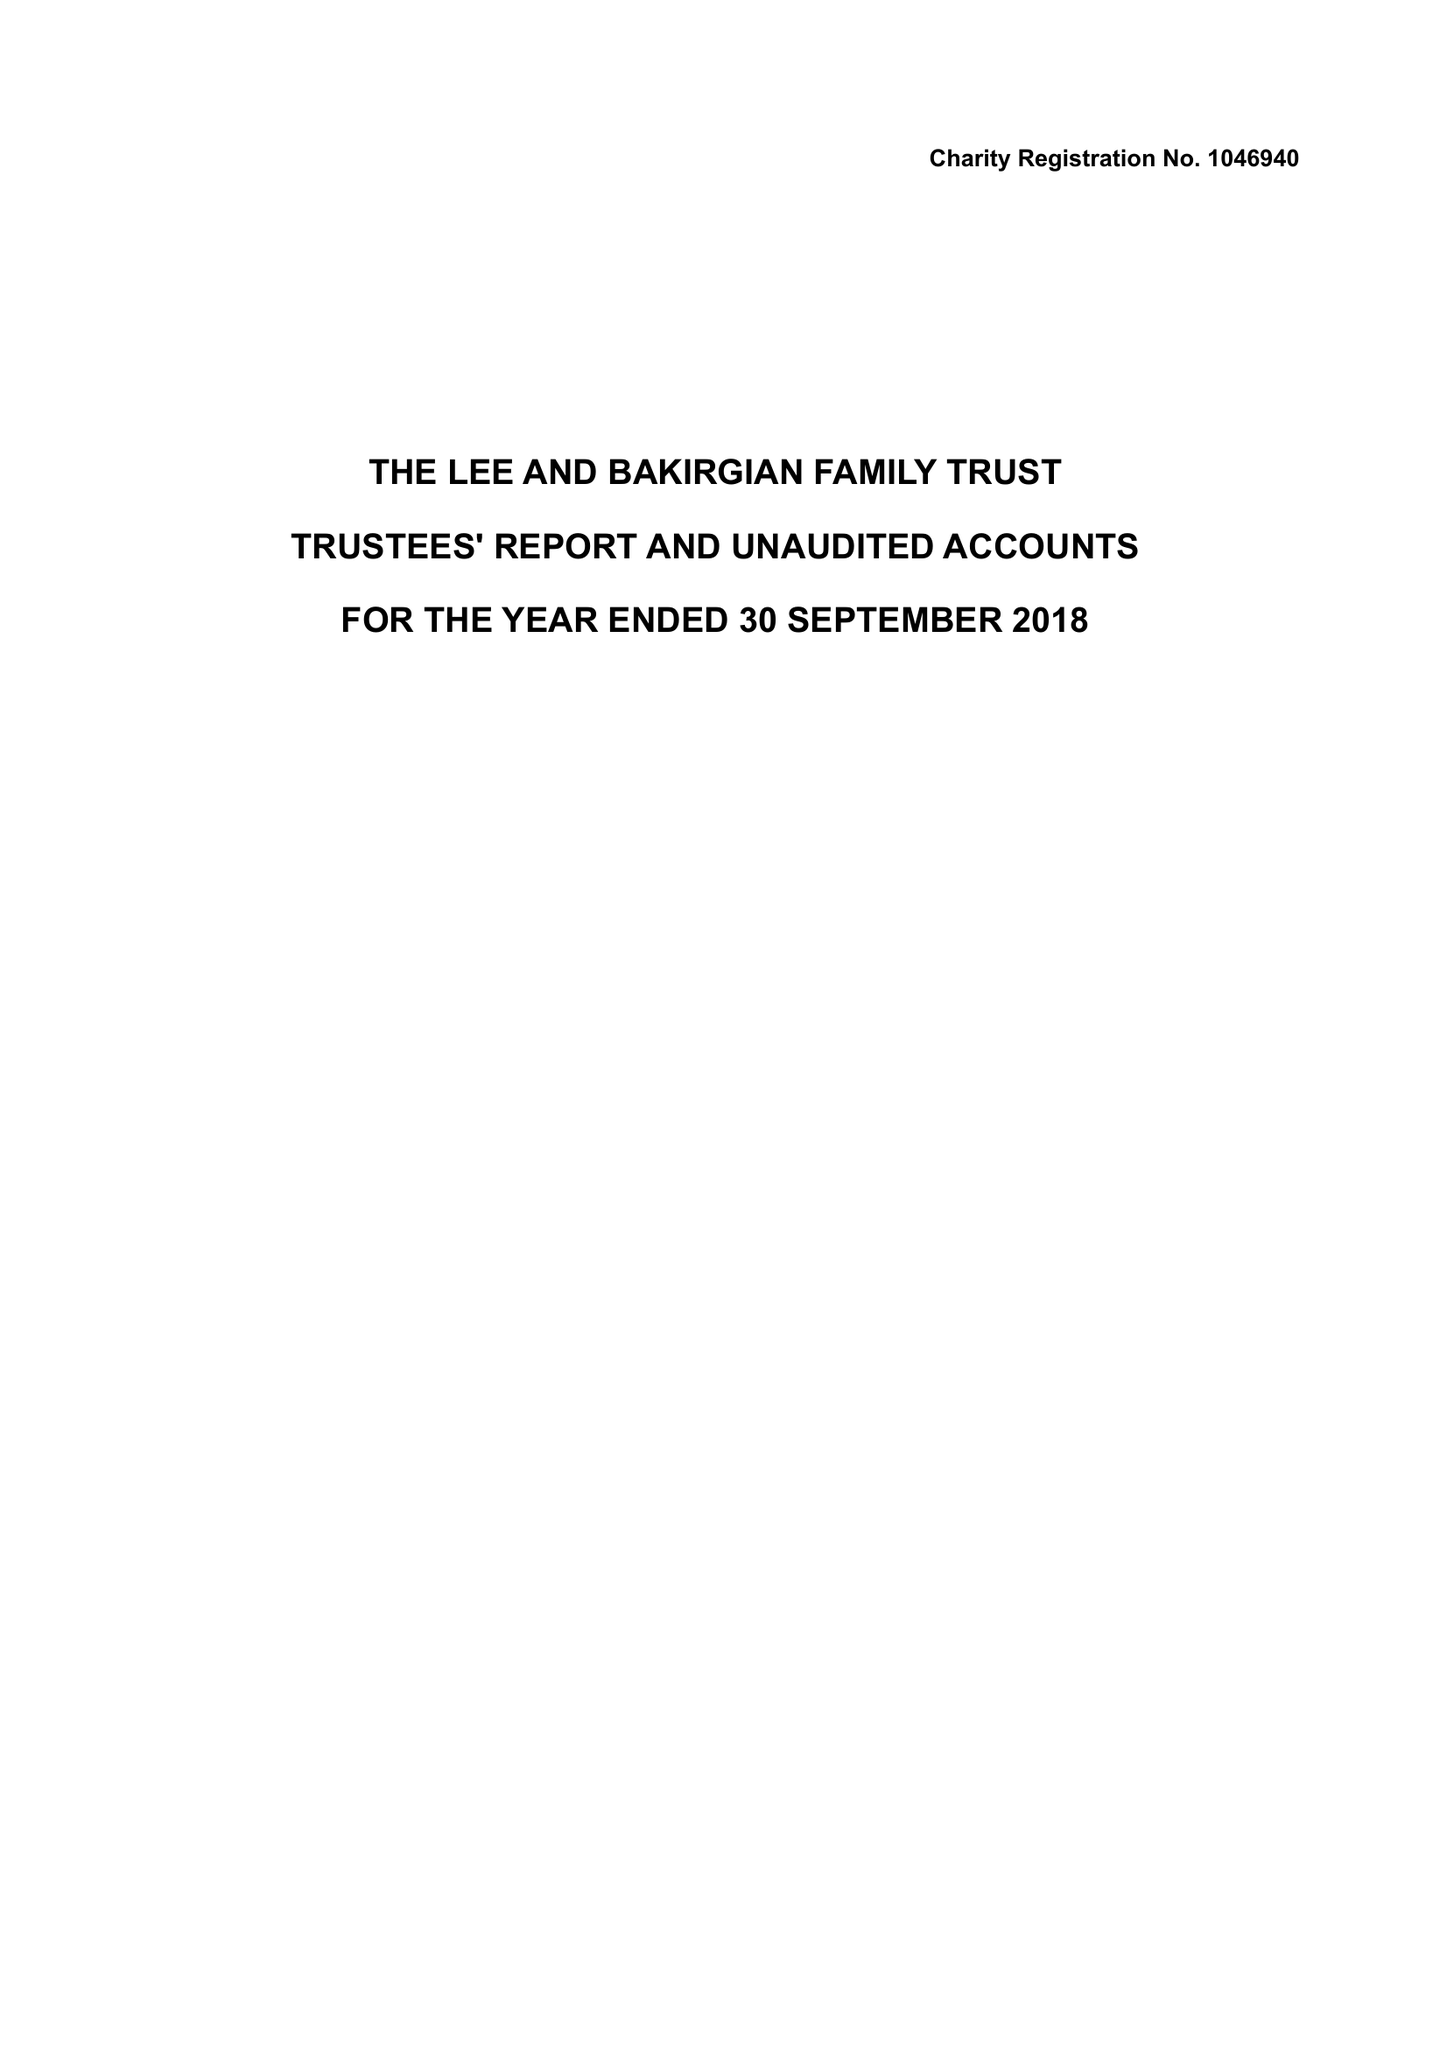What is the value for the address__street_line?
Answer the question using a single word or phrase. YEW TREE WAY 